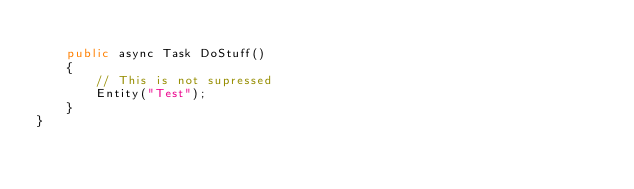Convert code to text. <code><loc_0><loc_0><loc_500><loc_500><_C#_>
    public async Task DoStuff()
    {
        // This is not supressed
        Entity("Test");
    }
}</code> 